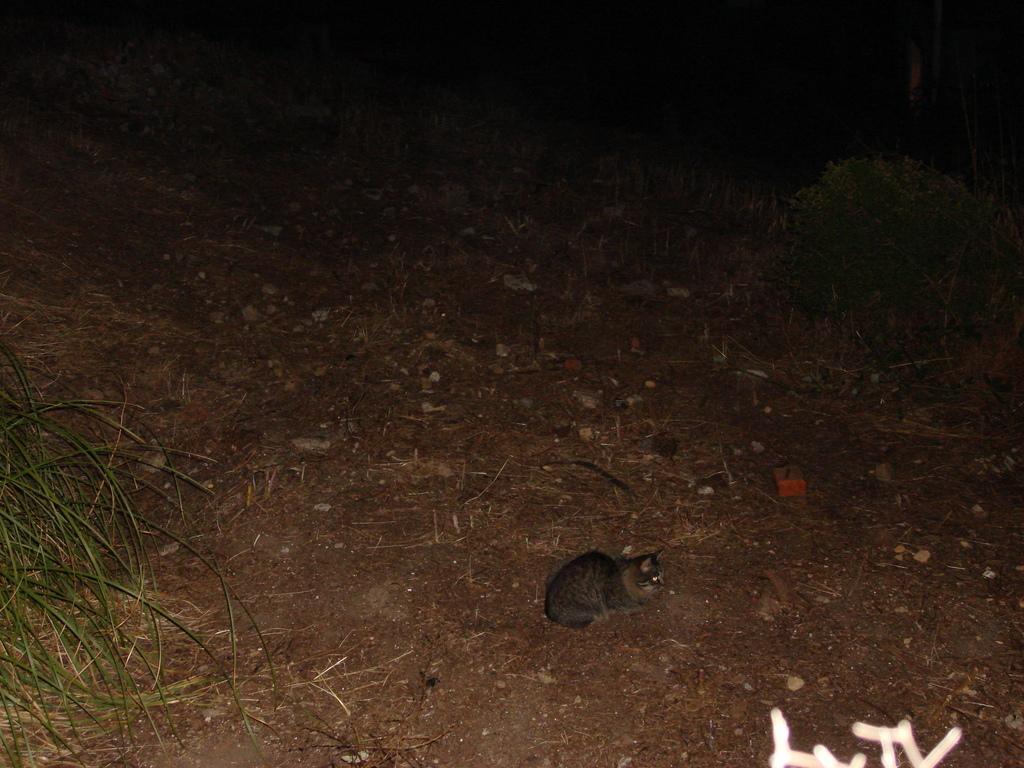In one or two sentences, can you explain what this image depicts? In this picture we can see a cat on the ground. Here we can see grass and there is a dark background. 